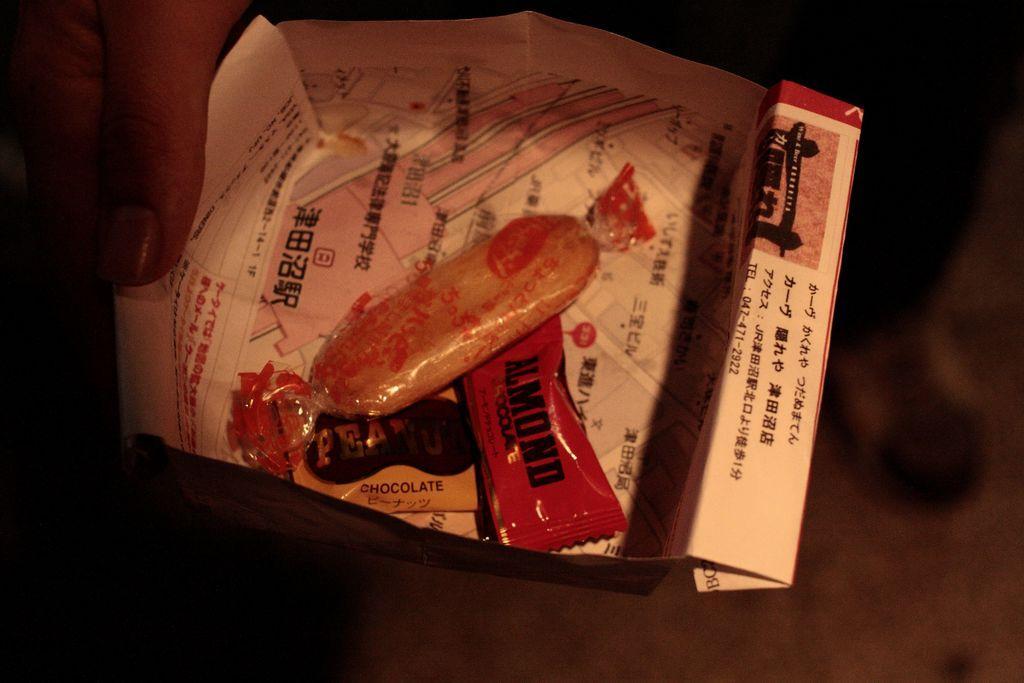Can you describe this image briefly? This picture is dark, in this picture we can see a person hand holding a box with candies. 